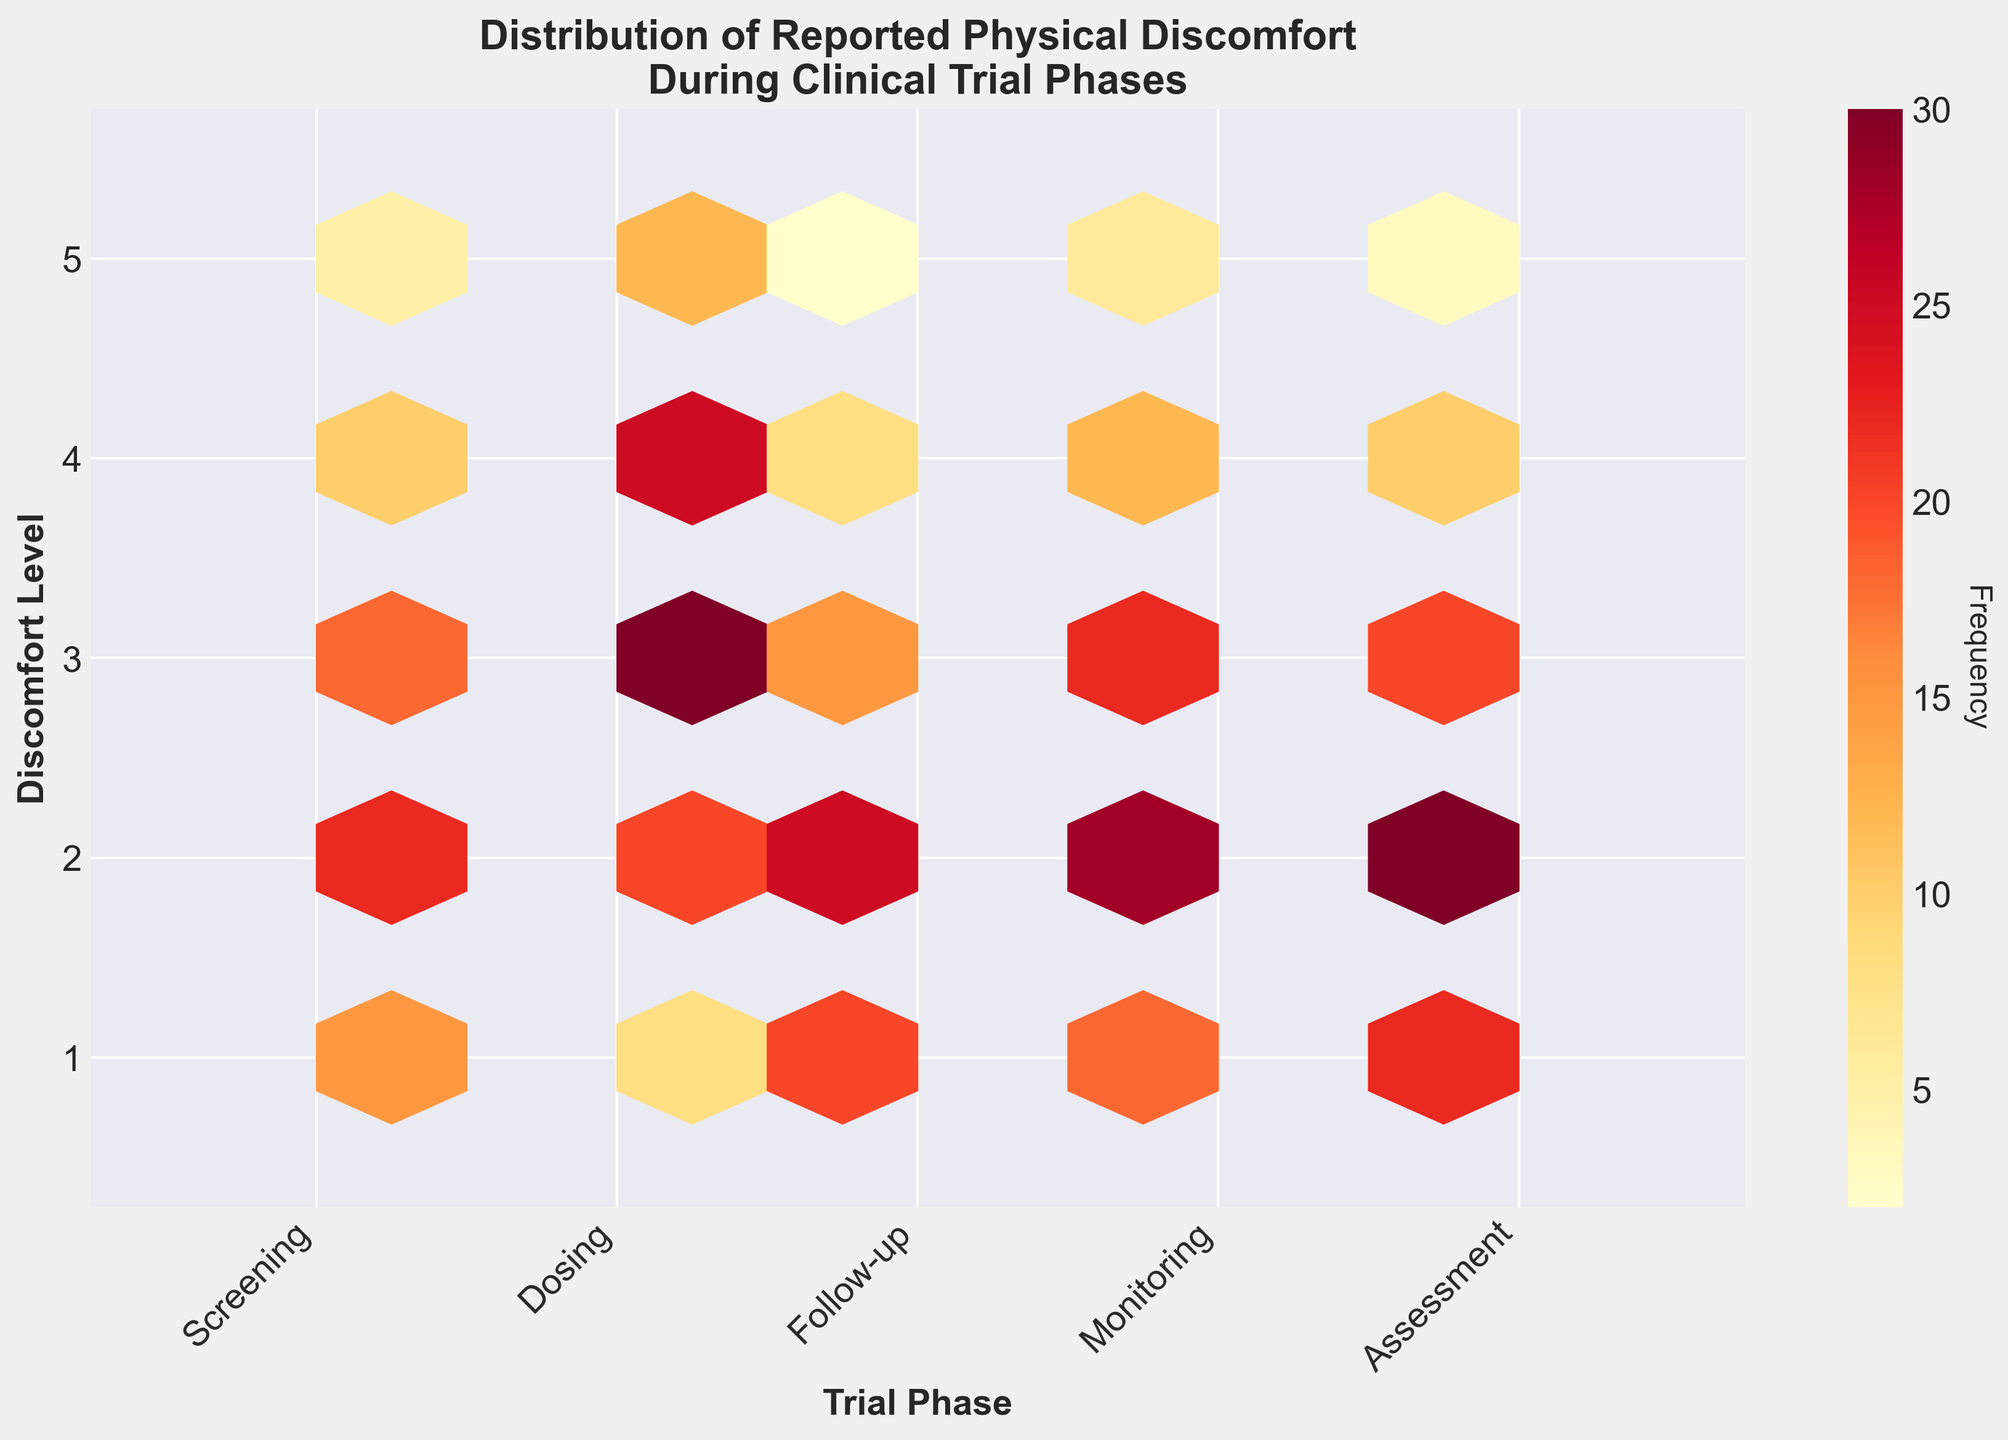What is the title of the plot? The title of the plot is located at the top part of the figure. It summarizes the main content of the plot. In this case, the title reads, "Distribution of Reported Physical Discomfort During Clinical Trial Phases."
Answer: Distribution of Reported Physical Discomfort During Clinical Trial Phases Which trial phase has the highest overall frequency of reported discomfort levels? Look at the hexbin plot and observe which trial phase has the most intense color (darkest hexagons) overall. The darkest hexagons are concentrated around the "Assessment" phase.
Answer: Assessment At what discomfort level does the "Dosing" phase have the highest frequency? Focus on the vertical axis label "Discomfort Level" and look at the hexagons present in the column representing "Dosing." The most intense color appears at discomfort level 3.
Answer: 3 Which discomfort level has the fewest reports in the "Follow-up" phase? For the "Follow-up" column, find the hexagon with the least color intensity or the smallest frequency label. The color is faintest at discomfort level 5.
Answer: 5 Does the "Screening" phase have any discomfort levels reported as zero frequency? Look at the column for the "Screening" phase and see if there are any areas that entirely lack hexagons. There are hexagons present, indicating that all discomfort levels have some reports.
Answer: No Which two phases have similar patterns of discomfort level distribution? Compare the intensity and location of hexagons for different phases. "Screening" and "Monitoring" have similar patterns with discomfort levels 2 and 3 showing higher frequencies.
Answer: Screening and Monitoring What is the overall trend of discomfort level frequencies as the clinical trial progresses from "Screening" to "Assessment"? Observe the color intensity of hexagons from left (Screening) to right (Assessment). The discomfort levels tend to increase and spread out as trials progress, with higher frequencies in mid discomfort levels during "Dosing" and "Assessment."
Answer: Increasing and spreading out In the "Assessment" phase, which discomfort levels show the highest and lowest frequencies? Look specifically at the hexagons in the "Assessment" column. The darkest hexagon (highest frequency) is at discomfort level 2, while the lightest hexagon (lowest frequency) is at discomfort level 5.
Answer: Highest: 2, Lowest: 5 